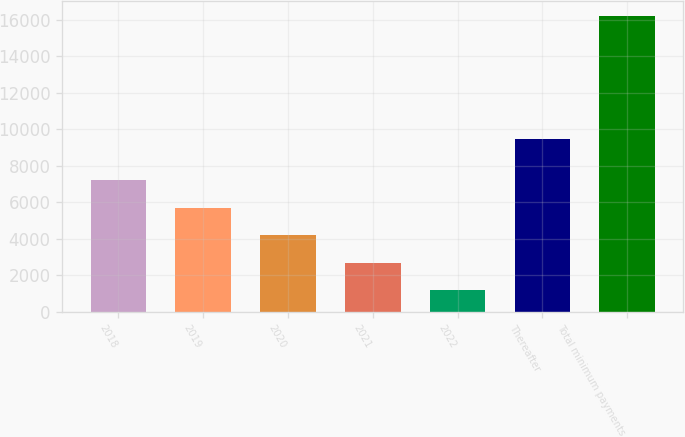Convert chart to OTSL. <chart><loc_0><loc_0><loc_500><loc_500><bar_chart><fcel>2018<fcel>2019<fcel>2020<fcel>2021<fcel>2022<fcel>Thereafter<fcel>Total minimum payments<nl><fcel>7190.68<fcel>5689.76<fcel>4188.84<fcel>2687.92<fcel>1187<fcel>9488.4<fcel>16196.2<nl></chart> 